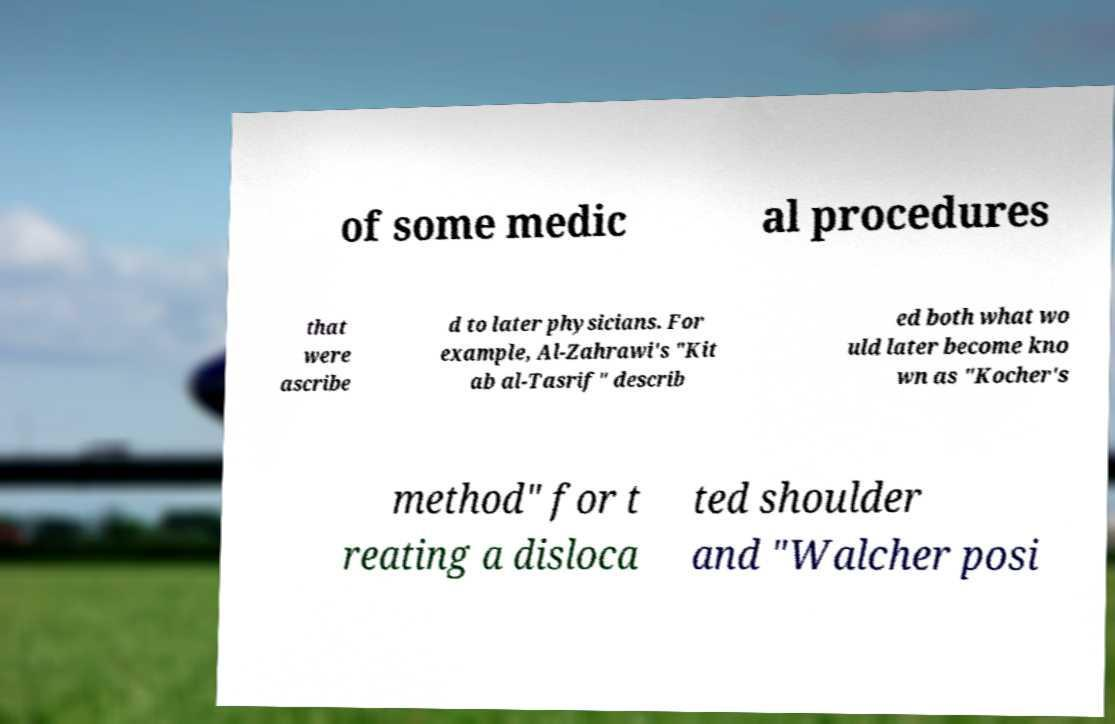Can you read and provide the text displayed in the image?This photo seems to have some interesting text. Can you extract and type it out for me? of some medic al procedures that were ascribe d to later physicians. For example, Al-Zahrawi's "Kit ab al-Tasrif" describ ed both what wo uld later become kno wn as "Kocher's method" for t reating a disloca ted shoulder and "Walcher posi 